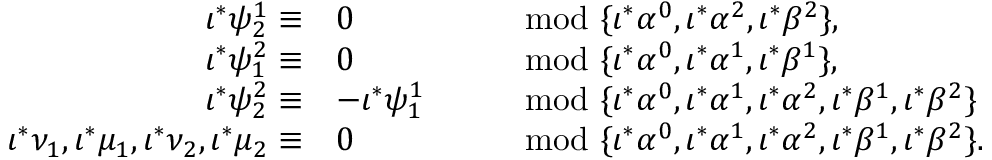<formula> <loc_0><loc_0><loc_500><loc_500>\begin{array} { r l r l } { \iota ^ { * } \psi _ { 2 } ^ { 1 } \equiv } & { 0 } & & { \mod \{ \iota ^ { * } \alpha ^ { 0 } , \iota ^ { * } \alpha ^ { 2 } , \iota ^ { * } \beta ^ { 2 } \} , } \\ { \iota ^ { * } \psi _ { 1 } ^ { 2 } \equiv } & { 0 } & & { \mod \{ \iota ^ { * } \alpha ^ { 0 } , \iota ^ { * } \alpha ^ { 1 } , \iota ^ { * } \beta ^ { 1 } \} , } \\ { \iota ^ { * } \psi _ { 2 } ^ { 2 } \equiv } & { - \iota ^ { * } \psi _ { 1 } ^ { 1 } } & & { \mod \{ \iota ^ { * } \alpha ^ { 0 } , \iota ^ { * } \alpha ^ { 1 } , \iota ^ { * } \alpha ^ { 2 } , \iota ^ { * } \beta ^ { 1 } , \iota ^ { * } \beta ^ { 2 } \} } \\ { \iota ^ { * } \nu _ { 1 } , \iota ^ { * } \mu _ { 1 } , \iota ^ { * } \nu _ { 2 } , \iota ^ { * } \mu _ { 2 } \equiv } & { 0 } & & { \mod \{ \iota ^ { * } \alpha ^ { 0 } , \iota ^ { * } \alpha ^ { 1 } , \iota ^ { * } \alpha ^ { 2 } , \iota ^ { * } \beta ^ { 1 } , \iota ^ { * } \beta ^ { 2 } \} . } \end{array}</formula> 